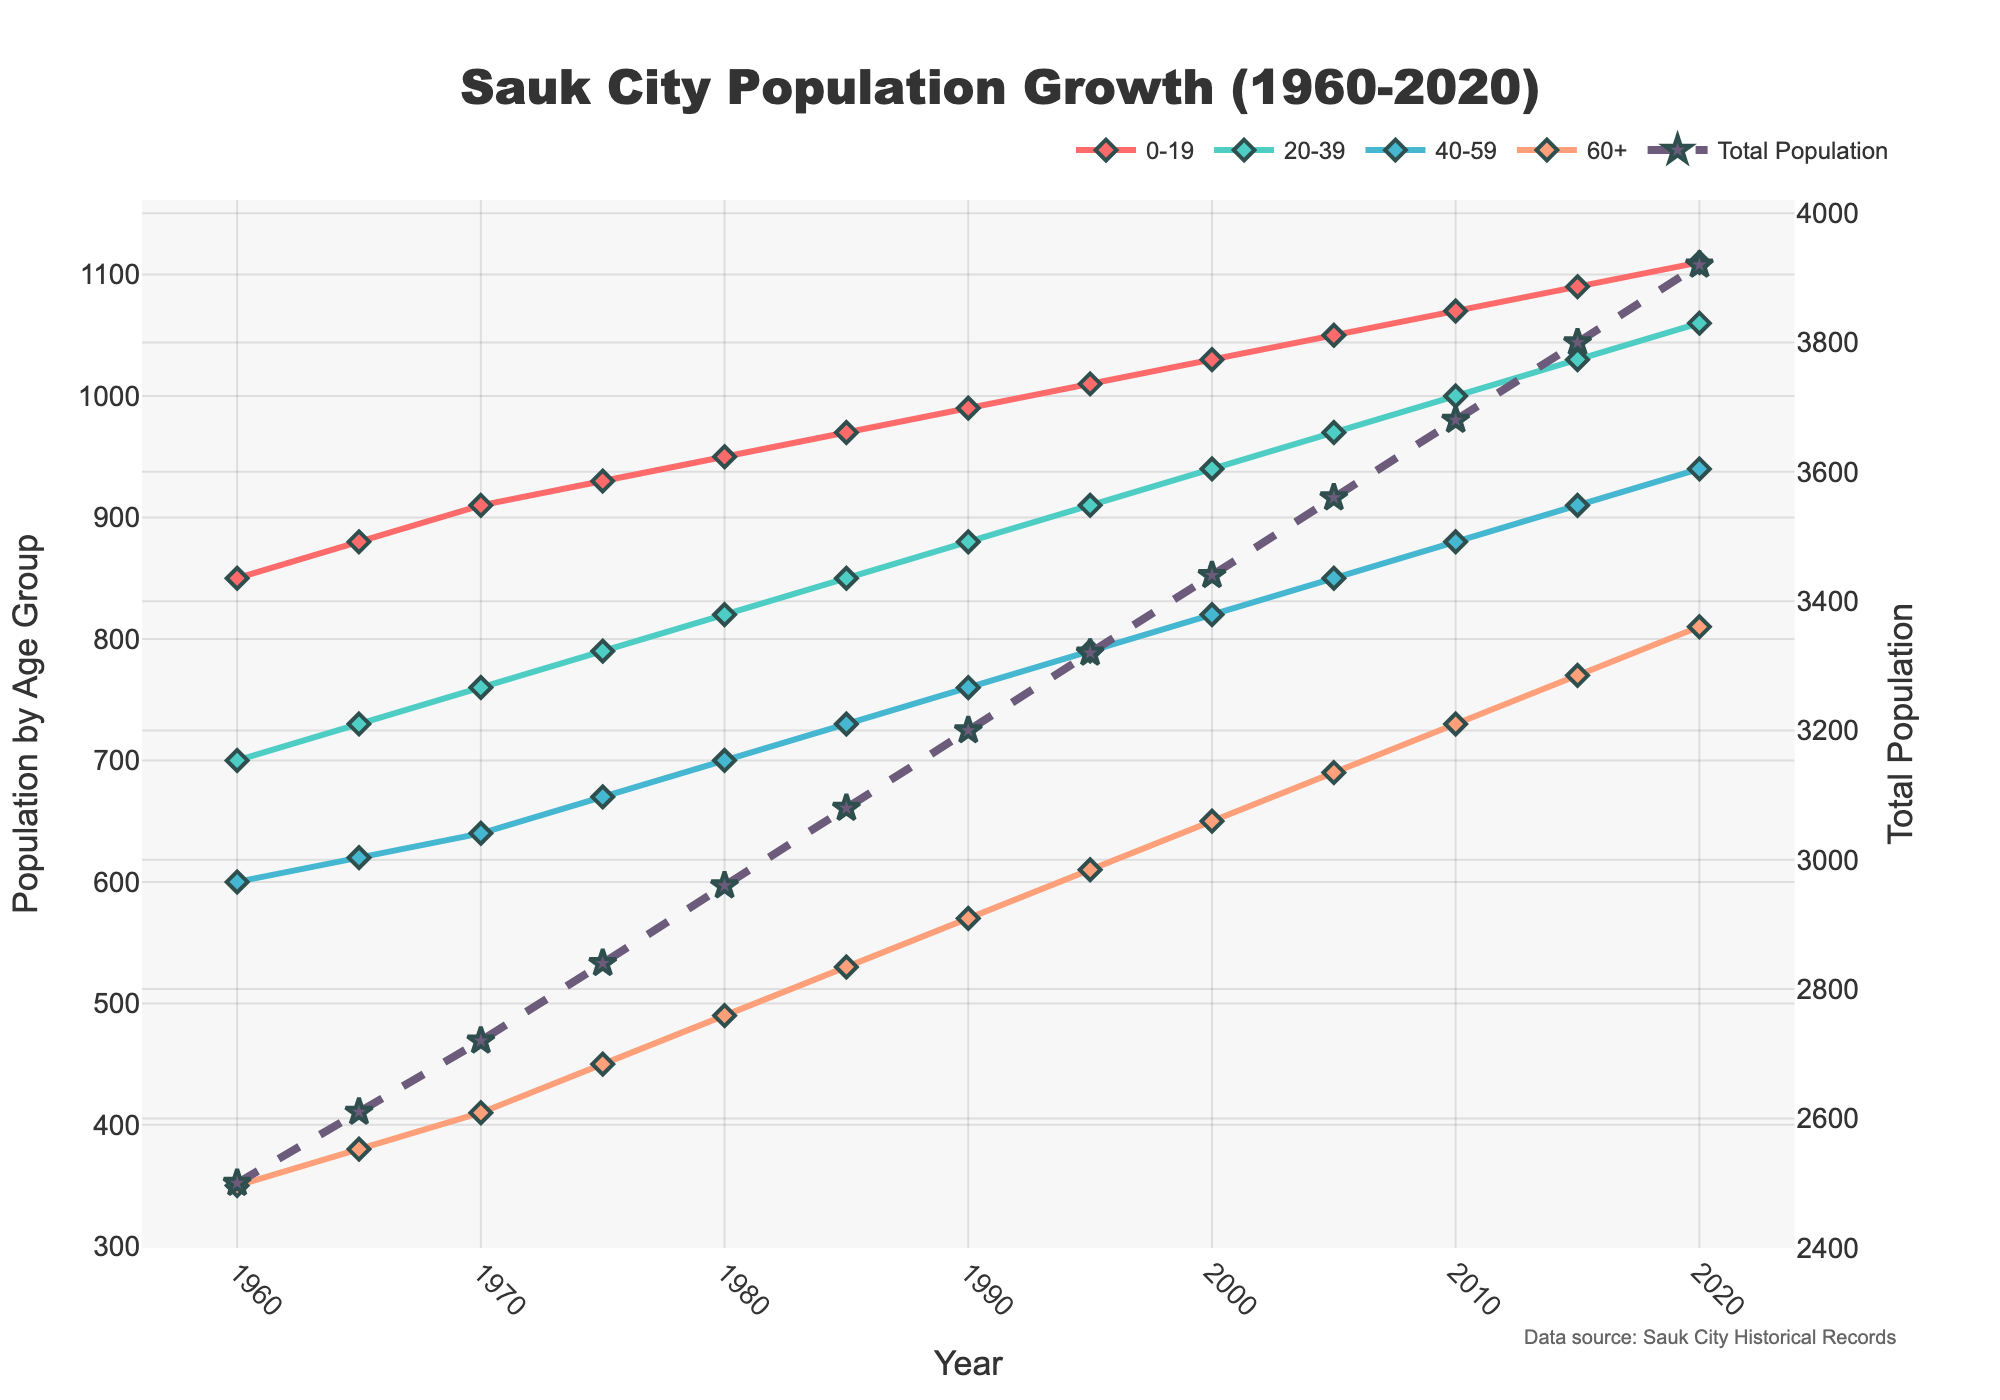What is the population trend for the 20-39 age group from 1960 to 2020? To identify the trend, observe the line representing the 20-39 age group. This line starts at 700 in 1960 and steadily increases to 1060 by 2020, indicating a continuous growth over the years.
Answer: Increasing In which year did the total population first exceed 3,000? Add the population numbers for all age groups in each year until the sum exceeds 3,000. The total population first exceeds 3,000 in 2010, where the sum is 3,680 (1070+1000+880+730).
Answer: 2010 By how much did the population of the 0-19 age group increase between 1960 and 2020? Subtract the population of the 0-19 age group in 1960 from its population in 2020. So, 1110 (2020) - 850 (1960) = 260.
Answer: 260 Which age group had the greatest population growth rate between 1960 and 2020? Compare the population growth of each age group from 1960 to 2020: 0-19 increased by 260, 20-39 increased by 360, 40-59 increased by 340, and 60+ increased by 460. The 60+ age group had the greatest growth.
Answer: 60+ In 1980, which two age groups had an approximately equal population? Compare the population values for all age groups in 1980. The 0-19 age group had 950 and the 20-39 age group had 820, which are not equal. The 40-59 group had 700 and the 60+ group had 490, also not equal. None of the age groups had approximately equal population.
Answer: None What is the difference in the total population between 1990 and 2020? Calculate the total population in 1990 (990+880+760+570=3200) and in 2020 (1110+1060+940+810=3920). The difference is 3920 - 3200 = 720.
Answer: 720 Which age group has the highest population in 2020, and what is its value? Check the population values for each age group in 2020. The highest is the 0-19 age group with 1110.
Answer: 0-19, 1110 How does the population of the 40-59 age group in 2000 compare to that of the 60+ age group in 1980? Look at the values: 40-59 age group in 2000 is 820 and 60+ age group in 1980 is 490. The former is greater than the latter.
Answer: Greater What is the mean population of the 60+ age group from 1960 to 2020? Add the population of the 60+ age group for all the years (350+380+410+450+490+530+570+610+650+690+730+770+810=8130) and divide by the number of years (13). So, 8130 / 13 ≈ 625.
Answer: 625 